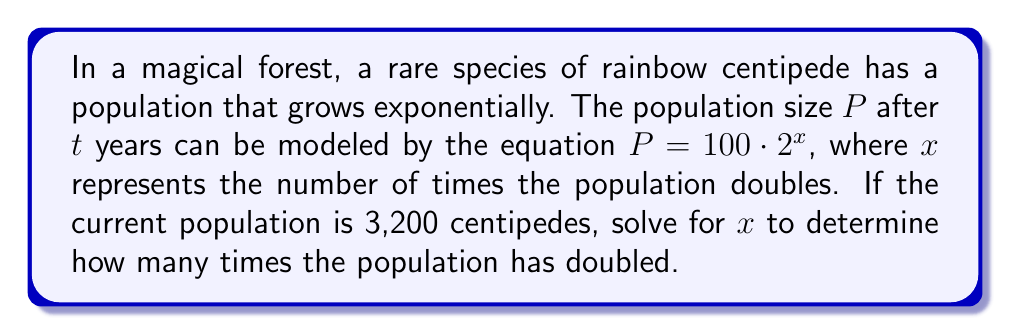Teach me how to tackle this problem. Let's solve this step-by-step:

1) We're given the equation $P = 100 \cdot 2^x$, where $P$ is the current population of 3,200.

2) Substitute the known values into the equation:
   $3200 = 100 \cdot 2^x$

3) Divide both sides by 100:
   $\frac{3200}{100} = 2^x$

4) Simplify:
   $32 = 2^x$

5) To solve for $x$, we need to take the logarithm (base 2) of both sides:
   $\log_2(32) = \log_2(2^x)$

6) The logarithm and exponent cancel on the right side:
   $\log_2(32) = x$

7) $\log_2(32)$ can be calculated:
   $2^5 = 32$, so $\log_2(32) = 5$

Therefore, $x = 5$
Answer: $x = 5$ 